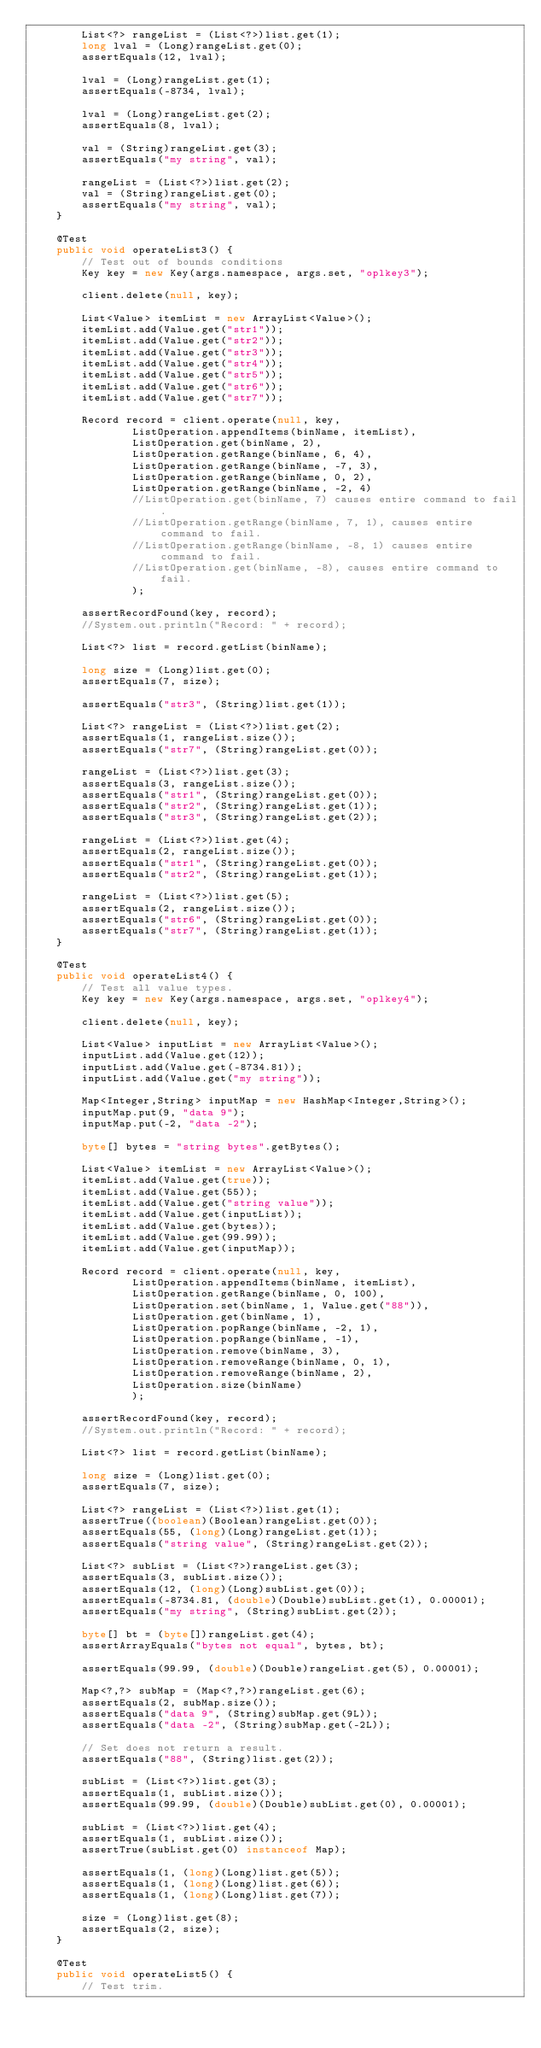Convert code to text. <code><loc_0><loc_0><loc_500><loc_500><_Java_>		List<?> rangeList = (List<?>)list.get(1);
		long lval = (Long)rangeList.get(0);
		assertEquals(12, lval);
		
		lval = (Long)rangeList.get(1);
		assertEquals(-8734, lval);

		lval = (Long)rangeList.get(2);
		assertEquals(8, lval);
		
		val = (String)rangeList.get(3);
		assertEquals("my string", val);
		
		rangeList = (List<?>)list.get(2);
		val = (String)rangeList.get(0);
		assertEquals("my string", val);
	}
	
	@Test
	public void operateList3() {
		// Test out of bounds conditions
		Key key = new Key(args.namespace, args.set, "oplkey3");
		
		client.delete(null, key);
		
		List<Value> itemList = new ArrayList<Value>();
		itemList.add(Value.get("str1"));
		itemList.add(Value.get("str2"));
		itemList.add(Value.get("str3"));
		itemList.add(Value.get("str4"));
		itemList.add(Value.get("str5"));
		itemList.add(Value.get("str6"));
		itemList.add(Value.get("str7"));

		Record record = client.operate(null, key,
				ListOperation.appendItems(binName, itemList),
				ListOperation.get(binName, 2),
				ListOperation.getRange(binName, 6, 4),
				ListOperation.getRange(binName, -7, 3),
				ListOperation.getRange(binName, 0, 2),
				ListOperation.getRange(binName, -2, 4)
				//ListOperation.get(binName, 7) causes entire command to fail.
				//ListOperation.getRange(binName, 7, 1), causes entire command to fail.
				//ListOperation.getRange(binName, -8, 1) causes entire command to fail.
				//ListOperation.get(binName, -8), causes entire command to fail.
				);
		
		assertRecordFound(key, record);
		//System.out.println("Record: " + record);
				
		List<?> list = record.getList(binName);
		
		long size = (Long)list.get(0);	
		assertEquals(7, size);
		
		assertEquals("str3", (String)list.get(1));
		
		List<?> rangeList = (List<?>)list.get(2);
		assertEquals(1, rangeList.size());
		assertEquals("str7", (String)rangeList.get(0));
		
		rangeList = (List<?>)list.get(3);
		assertEquals(3, rangeList.size());
		assertEquals("str1", (String)rangeList.get(0));
		assertEquals("str2", (String)rangeList.get(1));
		assertEquals("str3", (String)rangeList.get(2));
		
		rangeList = (List<?>)list.get(4);
		assertEquals(2, rangeList.size());
		assertEquals("str1", (String)rangeList.get(0));
		assertEquals("str2", (String)rangeList.get(1));
		
		rangeList = (List<?>)list.get(5);
		assertEquals(2, rangeList.size());
		assertEquals("str6", (String)rangeList.get(0));
		assertEquals("str7", (String)rangeList.get(1));
	}
	
	@Test
	public void operateList4() {
		// Test all value types.
		Key key = new Key(args.namespace, args.set, "oplkey4");
		
		client.delete(null, key);
		
		List<Value> inputList = new ArrayList<Value>();
		inputList.add(Value.get(12));
		inputList.add(Value.get(-8734.81));
		inputList.add(Value.get("my string"));
		
		Map<Integer,String> inputMap = new HashMap<Integer,String>();
		inputMap.put(9, "data 9");
		inputMap.put(-2, "data -2");

		byte[] bytes = "string bytes".getBytes();
		
		List<Value> itemList = new ArrayList<Value>();
		itemList.add(Value.get(true));
		itemList.add(Value.get(55));
		itemList.add(Value.get("string value"));
		itemList.add(Value.get(inputList));
		itemList.add(Value.get(bytes));
		itemList.add(Value.get(99.99));
		itemList.add(Value.get(inputMap));

		Record record = client.operate(null, key,
				ListOperation.appendItems(binName, itemList),
				ListOperation.getRange(binName, 0, 100),
				ListOperation.set(binName, 1, Value.get("88")),
				ListOperation.get(binName, 1),
				ListOperation.popRange(binName, -2, 1),
				ListOperation.popRange(binName, -1),
				ListOperation.remove(binName, 3),
				ListOperation.removeRange(binName, 0, 1),
				ListOperation.removeRange(binName, 2),
				ListOperation.size(binName)
				);
		
		assertRecordFound(key, record);
		//System.out.println("Record: " + record);
				
		List<?> list = record.getList(binName);
		
		long size = (Long)list.get(0);	
		assertEquals(7, size);
		
		List<?> rangeList = (List<?>)list.get(1);
		assertTrue((boolean)(Boolean)rangeList.get(0));
		assertEquals(55, (long)(Long)rangeList.get(1));
		assertEquals("string value", (String)rangeList.get(2));
		
		List<?> subList = (List<?>)rangeList.get(3);
		assertEquals(3, subList.size());	
		assertEquals(12, (long)(Long)subList.get(0));
		assertEquals(-8734.81, (double)(Double)subList.get(1), 0.00001);
		assertEquals("my string", (String)subList.get(2));
		
		byte[] bt = (byte[])rangeList.get(4);
		assertArrayEquals("bytes not equal", bytes, bt);
		
		assertEquals(99.99, (double)(Double)rangeList.get(5), 0.00001);

		Map<?,?> subMap = (Map<?,?>)rangeList.get(6);
		assertEquals(2, subMap.size());	
		assertEquals("data 9", (String)subMap.get(9L));	
		assertEquals("data -2", (String)subMap.get(-2L));
		
		// Set does not return a result.
		assertEquals("88", (String)list.get(2));
		
		subList = (List<?>)list.get(3);
		assertEquals(1, subList.size());	
		assertEquals(99.99, (double)(Double)subList.get(0), 0.00001);
		
		subList = (List<?>)list.get(4);
		assertEquals(1, subList.size());	
		assertTrue(subList.get(0) instanceof Map);

		assertEquals(1, (long)(Long)list.get(5));
		assertEquals(1, (long)(Long)list.get(6));
		assertEquals(1, (long)(Long)list.get(7));
		
		size = (Long)list.get(8);
		assertEquals(2, size);	
	}
	
	@Test
	public void operateList5() {
		// Test trim.</code> 